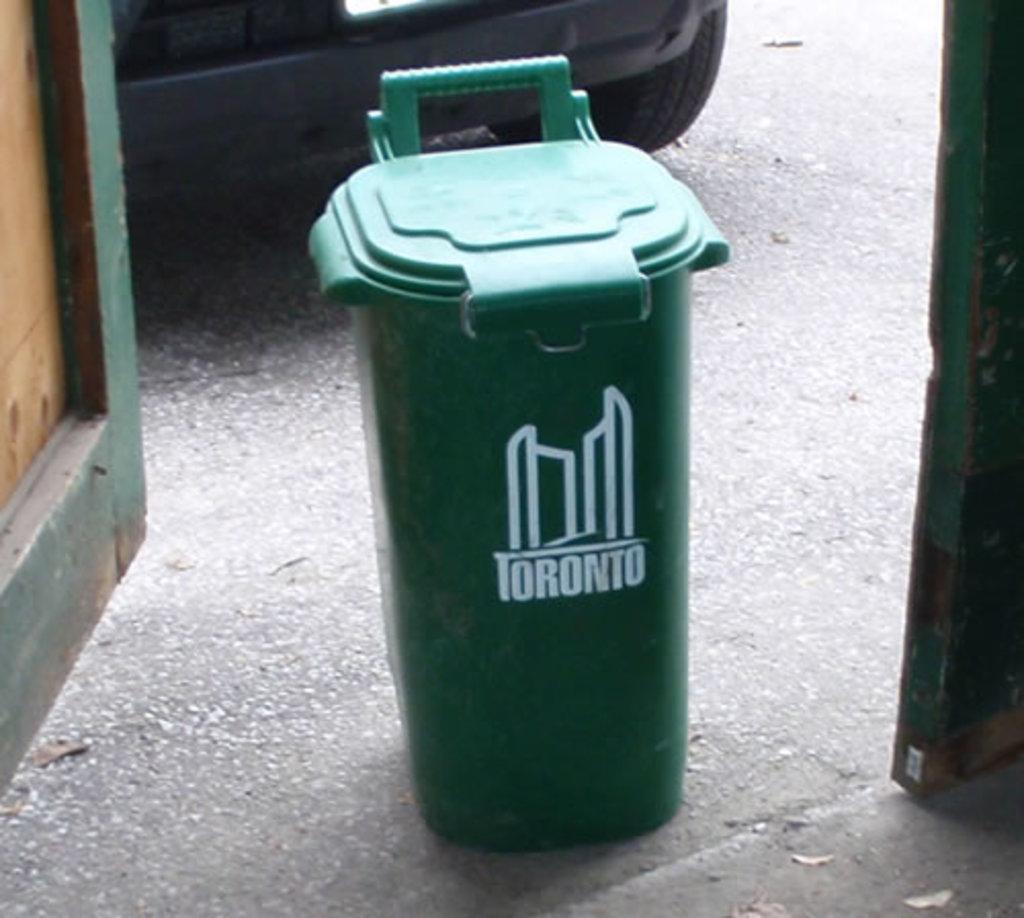What city are these trash cans in?
Offer a terse response. Toronto. What color are the city supplied trash receptacles?
Offer a terse response. Green. 